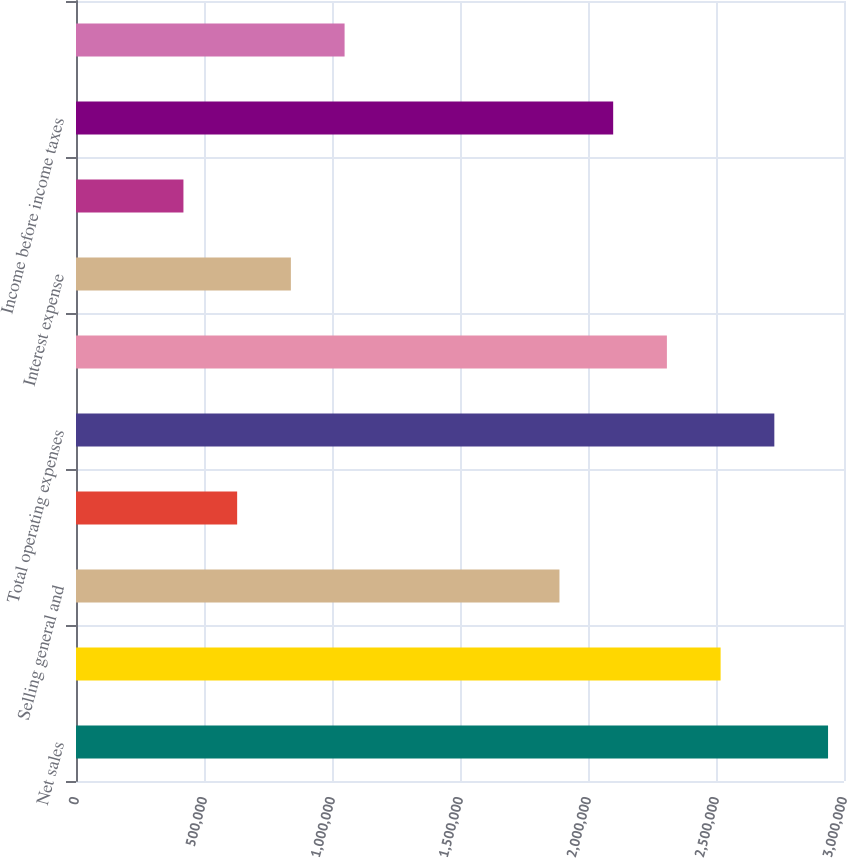Convert chart to OTSL. <chart><loc_0><loc_0><loc_500><loc_500><bar_chart><fcel>Net sales<fcel>Cost of sales excluding<fcel>Selling general and<fcel>Depreciation<fcel>Total operating expenses<fcel>Operating income<fcel>Interest expense<fcel>Other net<fcel>Income before income taxes<fcel>Provision for income taxes<nl><fcel>2.9377e+06<fcel>2.51803e+06<fcel>1.88852e+06<fcel>629508<fcel>2.72786e+06<fcel>2.30819e+06<fcel>839343<fcel>419673<fcel>2.09836e+06<fcel>1.04918e+06<nl></chart> 